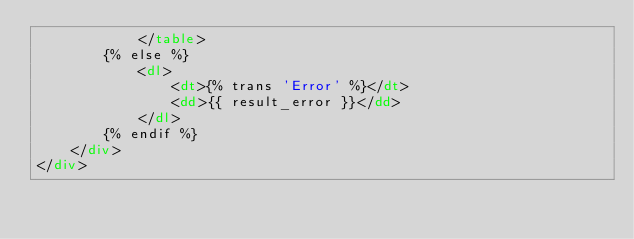Convert code to text. <code><loc_0><loc_0><loc_500><loc_500><_HTML_>			</table>
		{% else %}
			<dl>
				<dt>{% trans 'Error' %}</dt>
				<dd>{{ result_error }}</dd>
			</dl>
		{% endif %}
	</div>
</div>
</code> 